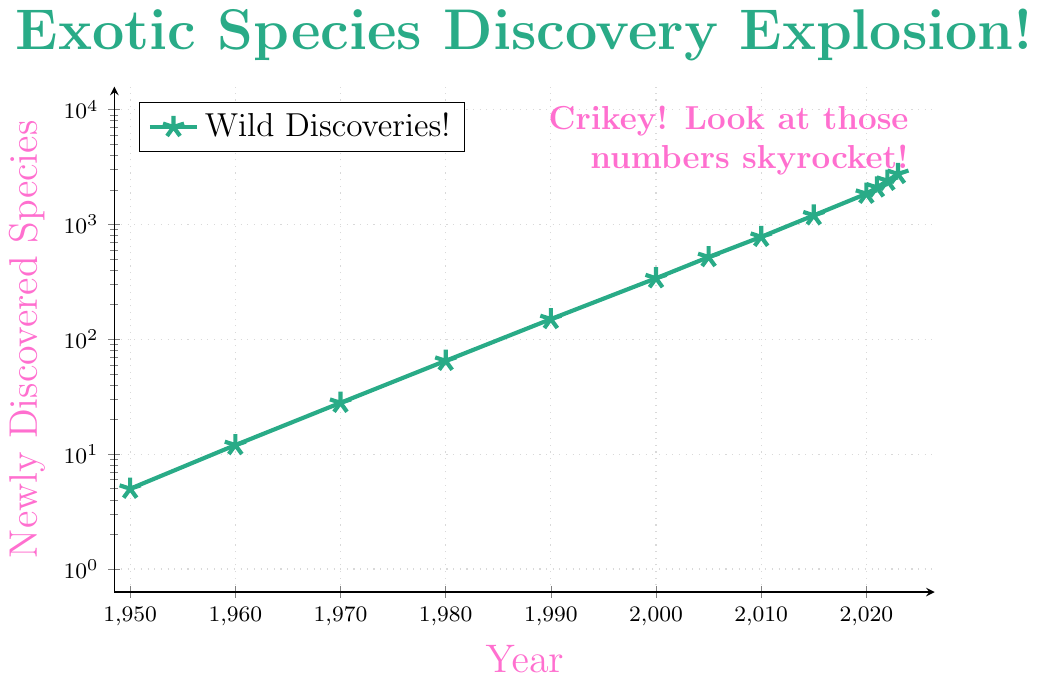which year had the smallest number of newly discovered species? The smallest number on the y-axis is closest to 5, and that corresponds to the year 1950 on the x-axis.
Answer: 1950 between 2010 and 2020, which year had more newly discovered species? We compare the y-values for the years 2010 (780 species) and 2020 (1850 species). 1850 is greater than 780, so the year 2020 had more newly discovered species.
Answer: 2020 what is the difference in the number of newly discovered species between 2015 and 2023? From the y-values, 2015 had 1200 newly discovered species and 2023 had 2750. The difference is 2750 - 1200 = 1550.
Answer: 1550 how many years does it take for the number of newly discovered species to roughly double from 150 to 340? The y-values show that there are 150 species in 1990 and 340 species in 2000. This is an approximate doubling, so it takes 2000 - 1990 = 10 years.
Answer: 10 years what is the visual cue used for the line color and the legend text color? The color of the line is green and the legend text is in pink. The green line represents the number of newly discovered species and is matched by the "Wild Discoveries!" legend.
Answer: green and pink what year sees a notable jump from under 1,000 to over 1,000 newly discovered species? The y-values show that in 2005 there were 520 species and in 2010 there were 780 species, both under 1000. In 2015, the number jumps to 1200, which is over 1000.
Answer: 2015 how many newly discovered species were there in the year just before the chart ends? At the end of the chart, which ends at 2023 with 2750 species, the preceding year is 2022, which had 2400 species.
Answer: 2400 compare the rate of increase in newly discovered species between the decades 1950-1960 and 1960-1970? From 1950 to 1960, the number increased from 5 to 12, a difference of 12 - 5 = 7 species. From 1960 to 1970, it increased from 12 to 28, a difference of 28 - 12 = 16 species. The rate of increase was higher in the 1960-1970 decade.
Answer: 1960-1970 how many data points lie above the 1000 species mark? The chart uses a y-axis in log scale, marking notable jumps in species numbers. Data points showing species numbers more than 1000 include years 2015 (1200), 2020 (1850), 2021 (2100), 2022 (2400), and 2023 (2750). So, there are 5 points above the 1000 species mark.
Answer: 5 